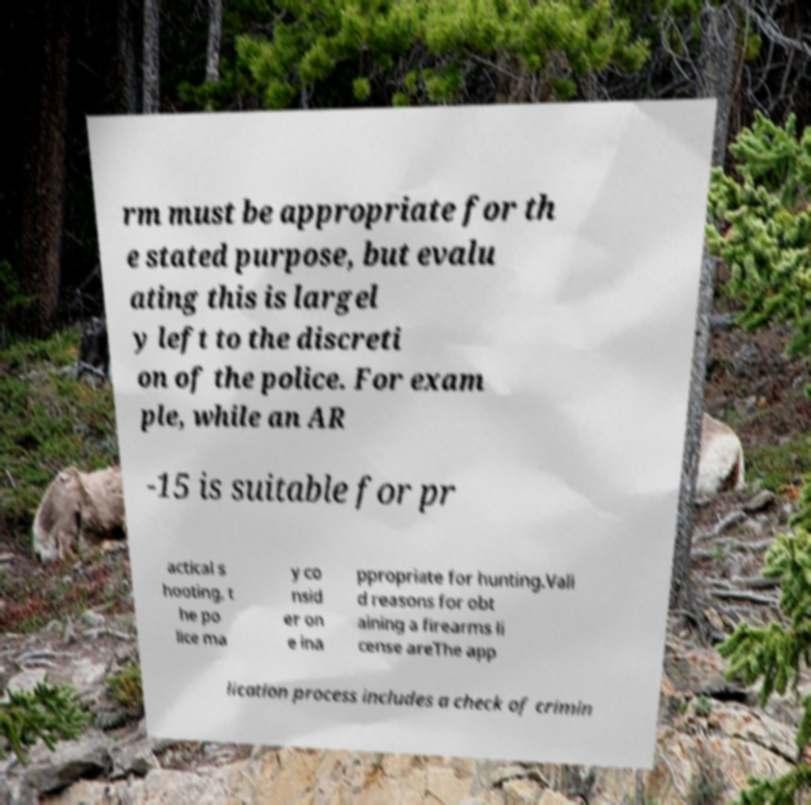Could you extract and type out the text from this image? rm must be appropriate for th e stated purpose, but evalu ating this is largel y left to the discreti on of the police. For exam ple, while an AR -15 is suitable for pr actical s hooting, t he po lice ma y co nsid er on e ina ppropriate for hunting.Vali d reasons for obt aining a firearms li cense areThe app lication process includes a check of crimin 